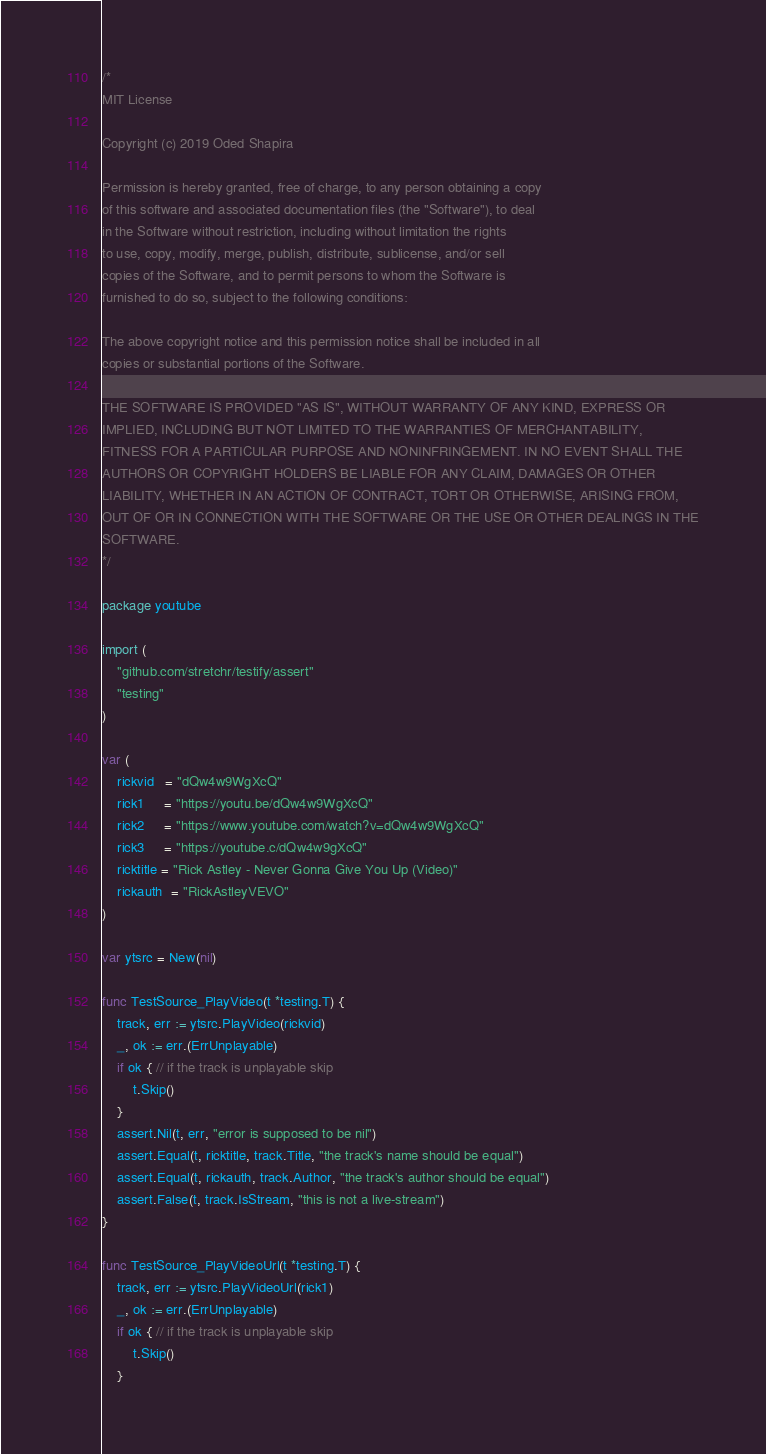Convert code to text. <code><loc_0><loc_0><loc_500><loc_500><_Go_>/*
MIT License

Copyright (c) 2019 Oded Shapira

Permission is hereby granted, free of charge, to any person obtaining a copy
of this software and associated documentation files (the "Software"), to deal
in the Software without restriction, including without limitation the rights
to use, copy, modify, merge, publish, distribute, sublicense, and/or sell
copies of the Software, and to permit persons to whom the Software is
furnished to do so, subject to the following conditions:

The above copyright notice and this permission notice shall be included in all
copies or substantial portions of the Software.

THE SOFTWARE IS PROVIDED "AS IS", WITHOUT WARRANTY OF ANY KIND, EXPRESS OR
IMPLIED, INCLUDING BUT NOT LIMITED TO THE WARRANTIES OF MERCHANTABILITY,
FITNESS FOR A PARTICULAR PURPOSE AND NONINFRINGEMENT. IN NO EVENT SHALL THE
AUTHORS OR COPYRIGHT HOLDERS BE LIABLE FOR ANY CLAIM, DAMAGES OR OTHER
LIABILITY, WHETHER IN AN ACTION OF CONTRACT, TORT OR OTHERWISE, ARISING FROM,
OUT OF OR IN CONNECTION WITH THE SOFTWARE OR THE USE OR OTHER DEALINGS IN THE
SOFTWARE.
*/

package youtube

import (
	"github.com/stretchr/testify/assert"
	"testing"
)

var (
	rickvid   = "dQw4w9WgXcQ"
	rick1     = "https://youtu.be/dQw4w9WgXcQ"
	rick2     = "https://www.youtube.com/watch?v=dQw4w9WgXcQ"
	rick3     = "https://youtube.c/dQw4w9gXcQ"
	ricktitle = "Rick Astley - Never Gonna Give You Up (Video)"
	rickauth  = "RickAstleyVEVO"
)

var ytsrc = New(nil)

func TestSource_PlayVideo(t *testing.T) {
	track, err := ytsrc.PlayVideo(rickvid)
	_, ok := err.(ErrUnplayable)
	if ok { // if the track is unplayable skip
		t.Skip()
	}
	assert.Nil(t, err, "error is supposed to be nil")
	assert.Equal(t, ricktitle, track.Title, "the track's name should be equal")
	assert.Equal(t, rickauth, track.Author, "the track's author should be equal")
	assert.False(t, track.IsStream, "this is not a live-stream")
}

func TestSource_PlayVideoUrl(t *testing.T) {
	track, err := ytsrc.PlayVideoUrl(rick1)
	_, ok := err.(ErrUnplayable)
	if ok { // if the track is unplayable skip
		t.Skip()
	}</code> 